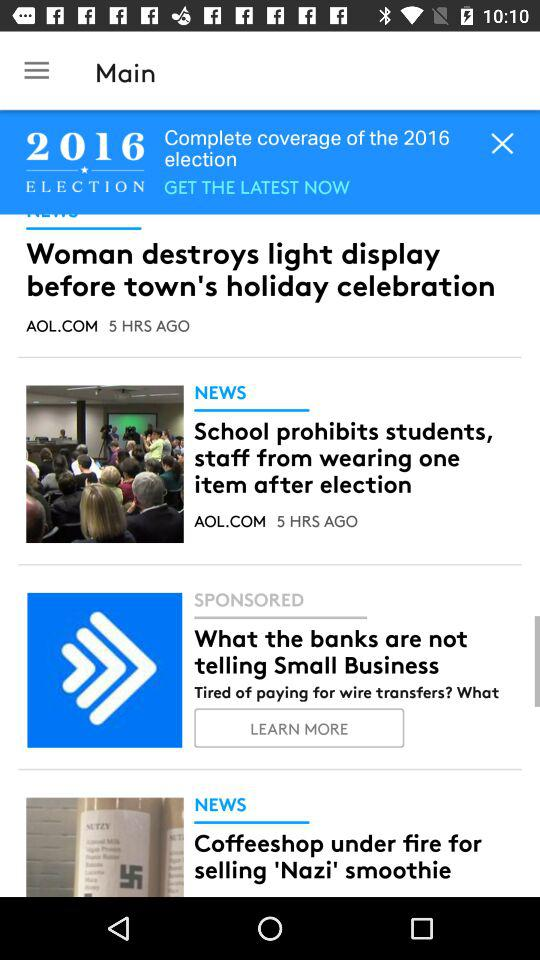How many stories are there in total?
Answer the question using a single word or phrase. 3 